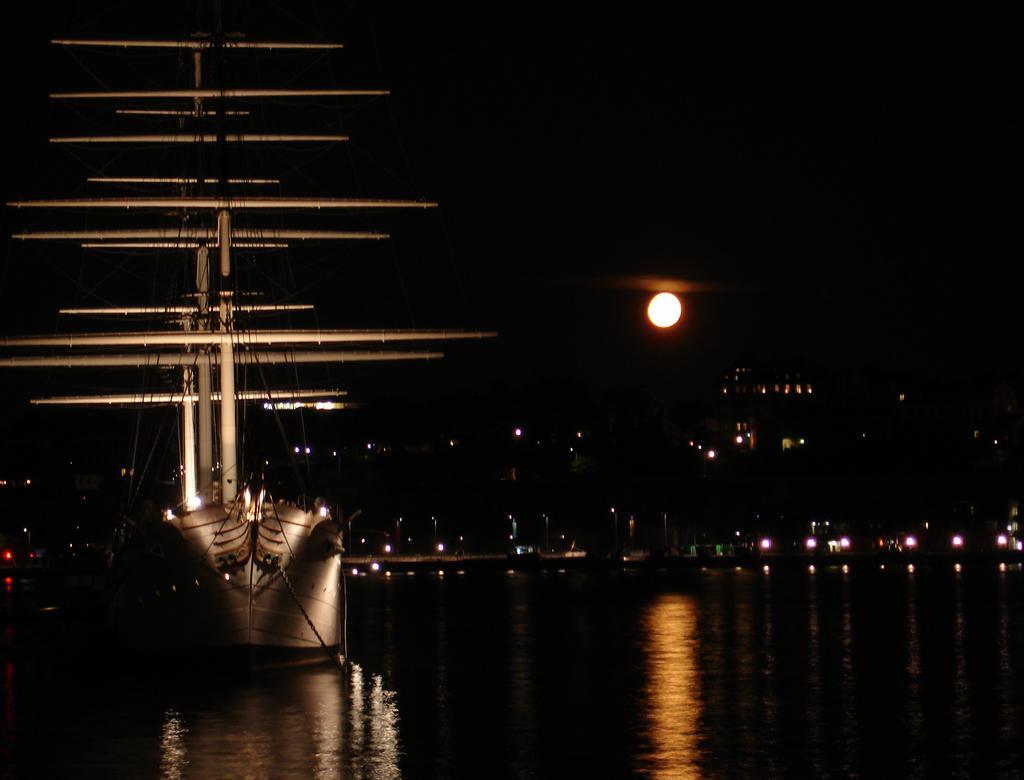Could you give a brief overview of what you see in this image? This image is taken during the night time. In this image we can see a boat on the surface of the water. In the background we can see the buildings, light poles, lights and also the moon. 